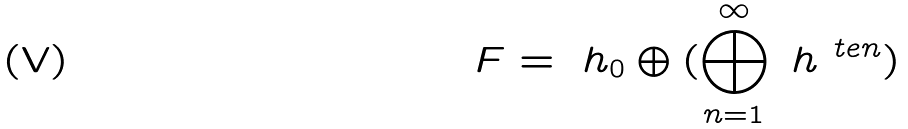Convert formula to latex. <formula><loc_0><loc_0><loc_500><loc_500>\ F = \ h _ { 0 } \oplus ( \bigoplus _ { n = 1 } ^ { \infty } \ h ^ { \ t e n } )</formula> 